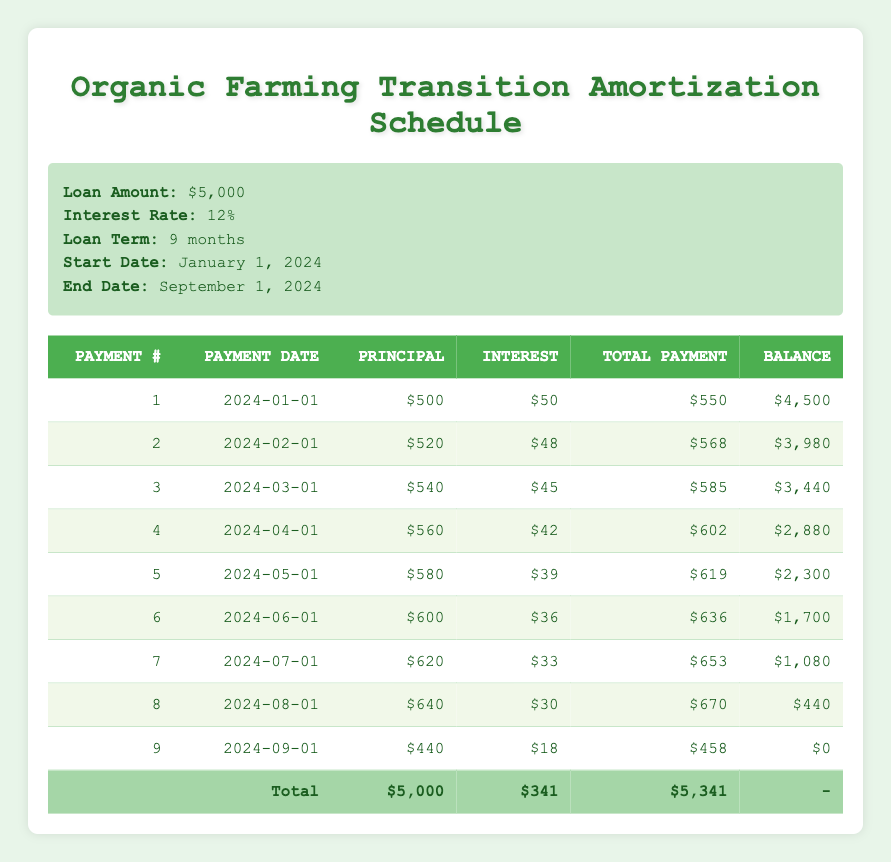What is the total amount paid by the end of the loan term? The total payment amount is found in the last row of the table, which shows the total of all payments made. Summing the 'Total Payment' column: 550 + 568 + 585 + 602 + 619 + 636 + 653 + 670 + 458 = 5,341.
Answer: 5,341 What was the outstanding balance after the first payment? The 'Outstanding Balance' for the first payment is directly listed in the table. After the first payment, it shows an outstanding balance of 4,500.
Answer: 4,500 How much interest was paid over the entire loan term? To find the total interest paid, sum the 'Interest Payment' column across all payments: 50 + 48 + 45 + 42 + 39 + 36 + 33 + 30 + 18 = 341.
Answer: 341 What was the change in total payment from payment 1 to payment 9? To find the change, subtract the 'Total Payment' of payment 1 from the 'Total Payment' of payment 9: 458 - 550 = -92. This indicates that the total payment decreased by 92 from the first to the last payment.
Answer: -92 Was the principal payment greater than the interest payment in every payment? By reviewing each payment row, the principal is greater than the interest in all payments except the last one where the principal payment was 440 and the interest was 18. Therefore, the answer is no.
Answer: No Which payment had the highest principal payment and what was that amount? Review the 'Principal Payment' column to identify the maximum value. Payment 8 has the highest principal payment of 640.
Answer: 640 How many months did it take to fully pay off the loan? The loan was structured over a period of 9 months from January 2024 to September 2024, as reflected in the 'Loan Term'. Thus, it took 9 months to pay off the loan.
Answer: 9 What was the outstanding balance after the fifth payment? Reference the table to find the outstanding balance listed immediately after the fifth payment, which shows an outstanding balance of 2,300.
Answer: 2,300 What is the average total payment made per month? To calculate the average, total all monthly payments and divide by the number of months: Average = Total Payments / Number of Payments = 5,341 / 9 ≈ 593.44.
Answer: 593.44 